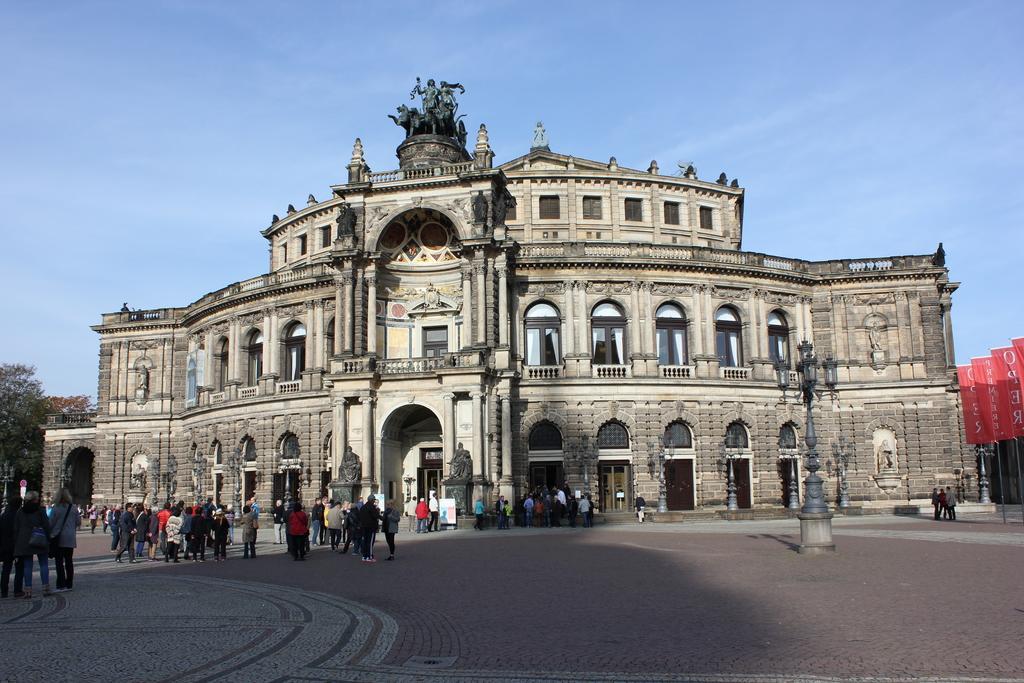How would you summarize this image in a sentence or two? As we can see in the image there are buildings, windows, street lamps, banners, trees and few people. At the top there is sky. 